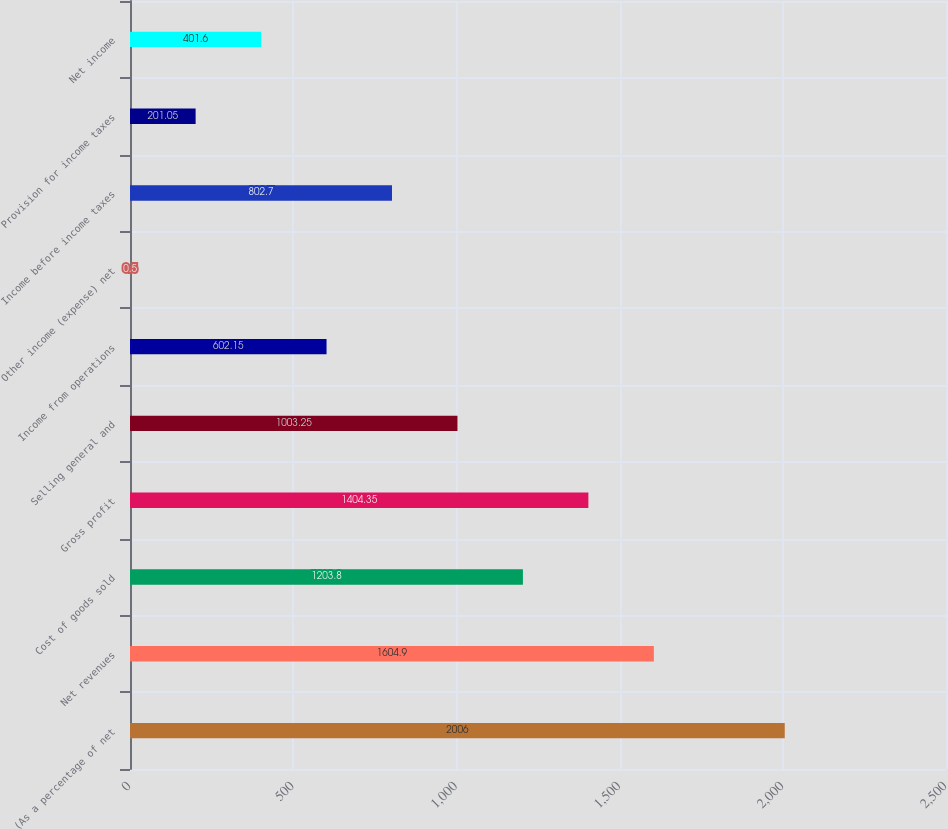Convert chart. <chart><loc_0><loc_0><loc_500><loc_500><bar_chart><fcel>(As a percentage of net<fcel>Net revenues<fcel>Cost of goods sold<fcel>Gross profit<fcel>Selling general and<fcel>Income from operations<fcel>Other income (expense) net<fcel>Income before income taxes<fcel>Provision for income taxes<fcel>Net income<nl><fcel>2006<fcel>1604.9<fcel>1203.8<fcel>1404.35<fcel>1003.25<fcel>602.15<fcel>0.5<fcel>802.7<fcel>201.05<fcel>401.6<nl></chart> 